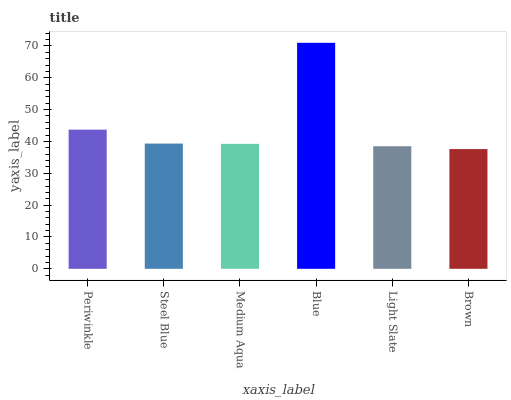Is Brown the minimum?
Answer yes or no. Yes. Is Blue the maximum?
Answer yes or no. Yes. Is Steel Blue the minimum?
Answer yes or no. No. Is Steel Blue the maximum?
Answer yes or no. No. Is Periwinkle greater than Steel Blue?
Answer yes or no. Yes. Is Steel Blue less than Periwinkle?
Answer yes or no. Yes. Is Steel Blue greater than Periwinkle?
Answer yes or no. No. Is Periwinkle less than Steel Blue?
Answer yes or no. No. Is Steel Blue the high median?
Answer yes or no. Yes. Is Medium Aqua the low median?
Answer yes or no. Yes. Is Blue the high median?
Answer yes or no. No. Is Blue the low median?
Answer yes or no. No. 